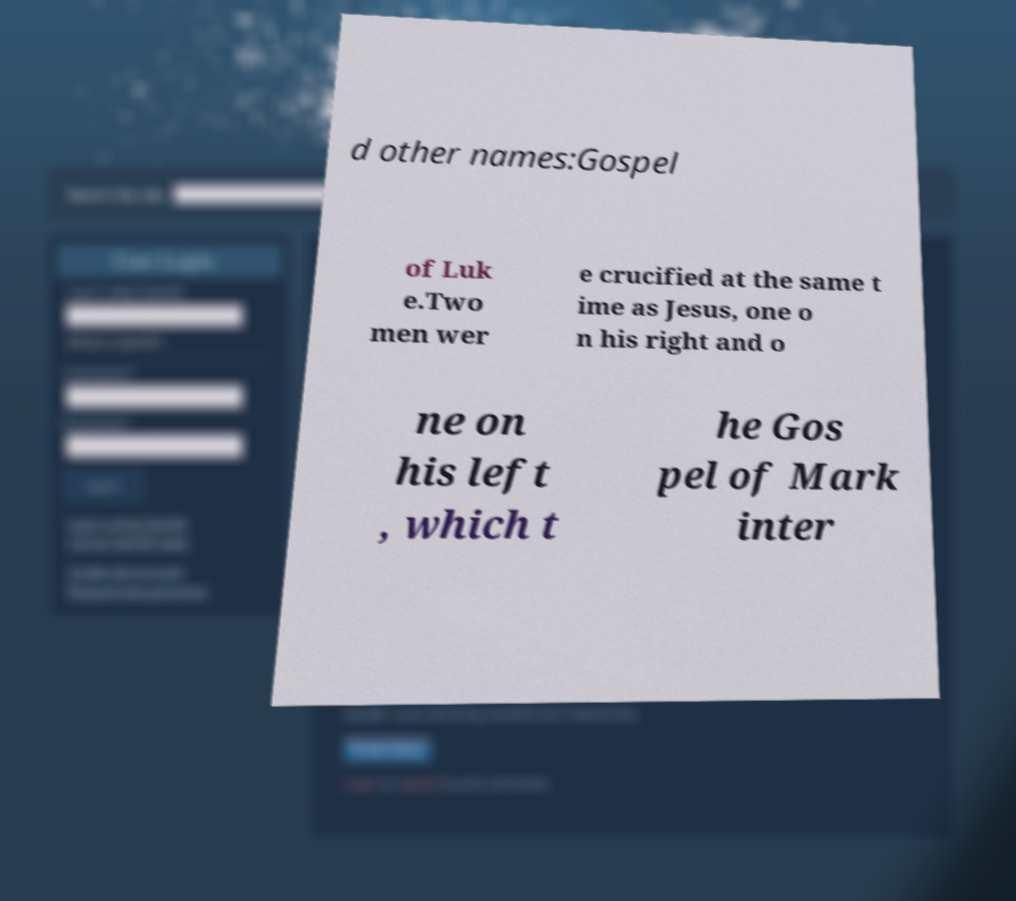For documentation purposes, I need the text within this image transcribed. Could you provide that? d other names:Gospel of Luk e.Two men wer e crucified at the same t ime as Jesus, one o n his right and o ne on his left , which t he Gos pel of Mark inter 